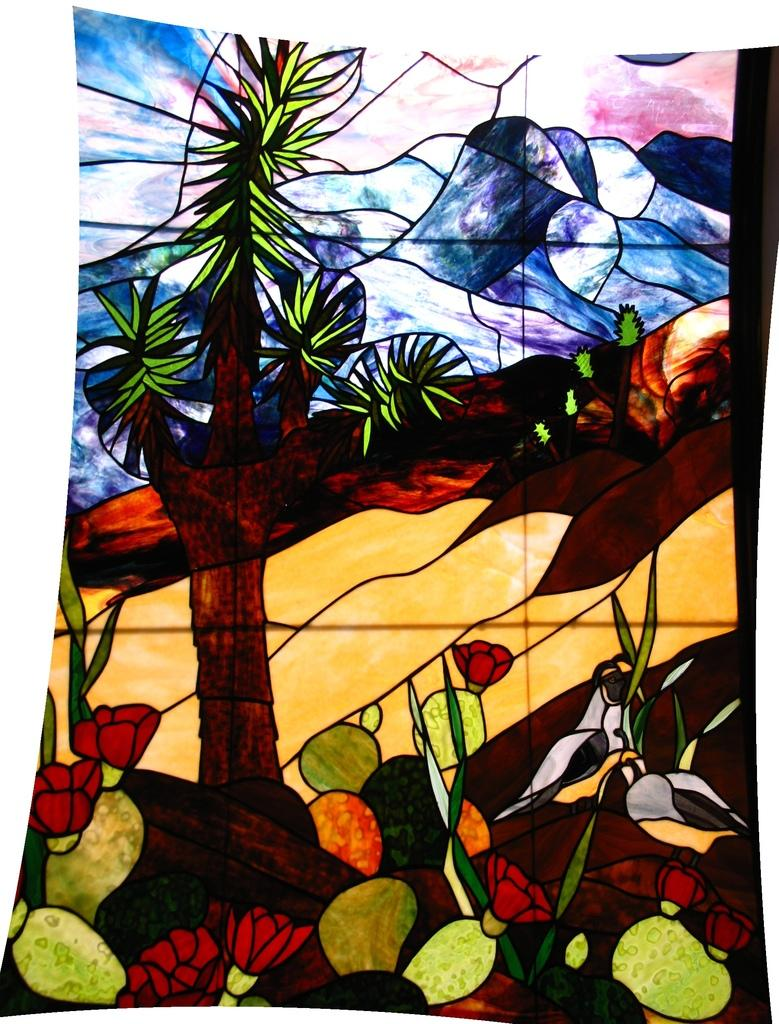What is the main subject of the painting in the image? The painting contains a tree, flowers, hills, and plants. Can you describe the landscape depicted in the painting? The painting contains a tree, flowers, hills, and plants, which suggests a natural landscape. What type of vegetation is present in the painting? The painting contains flowers and plants. Are there any man-made structures or objects in the painting? The facts provided do not mention any man-made structures or objects in the painting. What type of dirt can be seen on the temper of the painting in the image? There is no dirt or temper mentioned in the image, as it is a painting of a landscape with a tree, flowers, hills, and plants. 